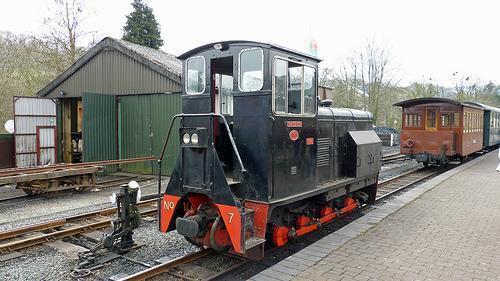How many train cars are there?
Give a very brief answer. 3. How many train cars are behind the locomotive?
Give a very brief answer. 2. 